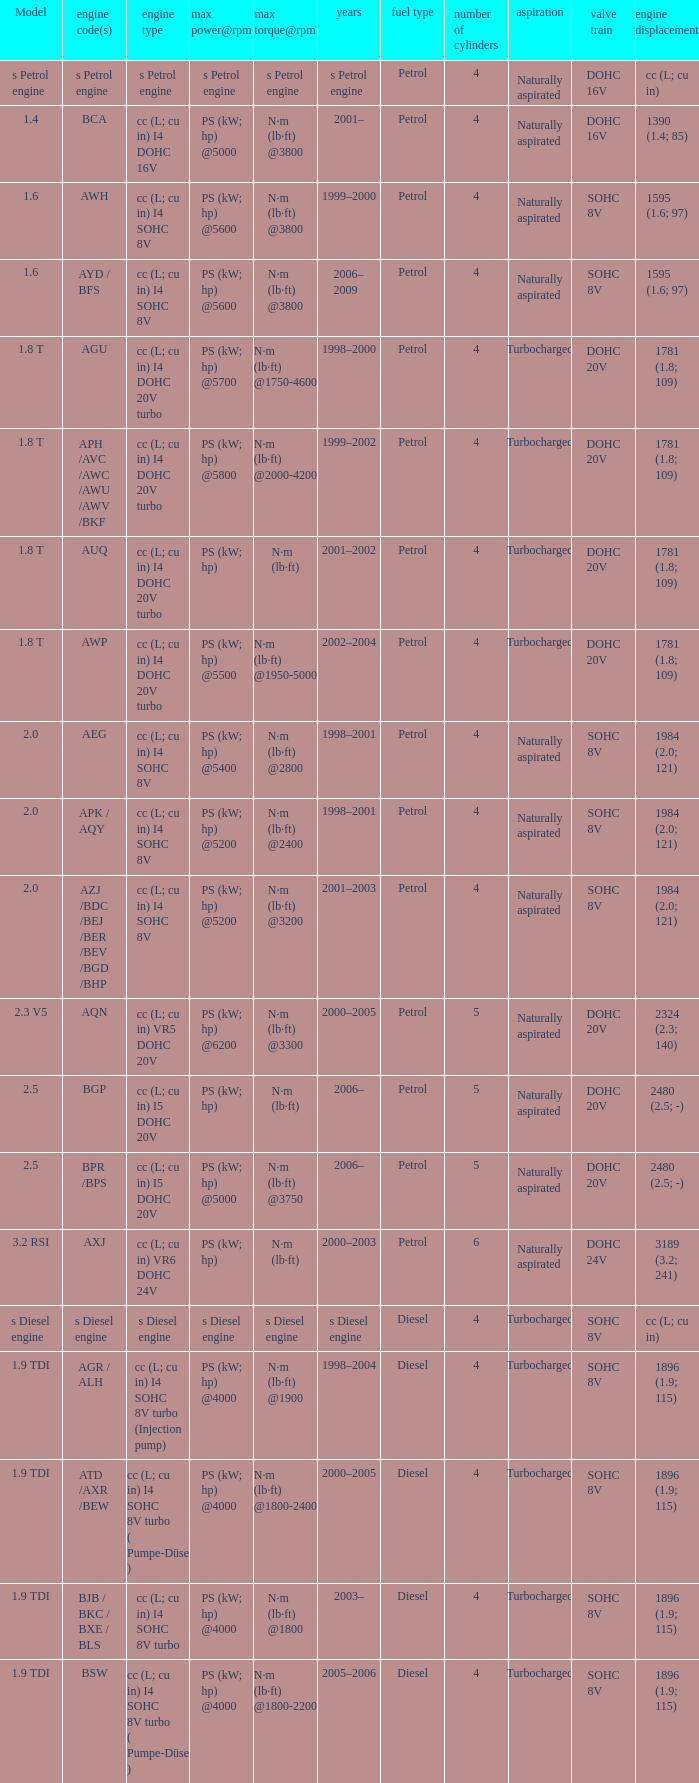What was the max torque@rpm of the engine which had the model 2.5  and a max power@rpm of ps (kw; hp) @5000? N·m (lb·ft) @3750. 